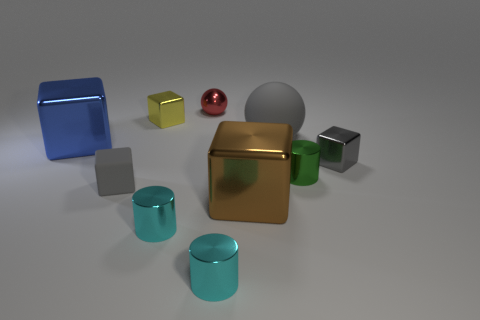Subtract all brown cylinders. How many gray blocks are left? 2 Subtract all small gray rubber cubes. How many cubes are left? 4 Subtract 2 blocks. How many blocks are left? 3 Subtract all brown cubes. How many cubes are left? 4 Subtract all cylinders. How many objects are left? 7 Subtract 1 green cylinders. How many objects are left? 9 Subtract all cyan cylinders. Subtract all gray cubes. How many cylinders are left? 1 Subtract all big blue metallic objects. Subtract all gray metal things. How many objects are left? 8 Add 8 rubber blocks. How many rubber blocks are left? 9 Add 8 gray cubes. How many gray cubes exist? 10 